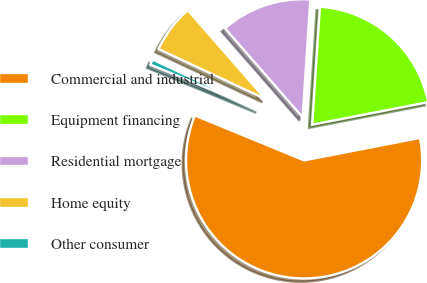Convert chart. <chart><loc_0><loc_0><loc_500><loc_500><pie_chart><fcel>Commercial and industrial<fcel>Equipment financing<fcel>Residential mortgage<fcel>Home equity<fcel>Other consumer<nl><fcel>59.26%<fcel>20.92%<fcel>12.46%<fcel>6.61%<fcel>0.76%<nl></chart> 